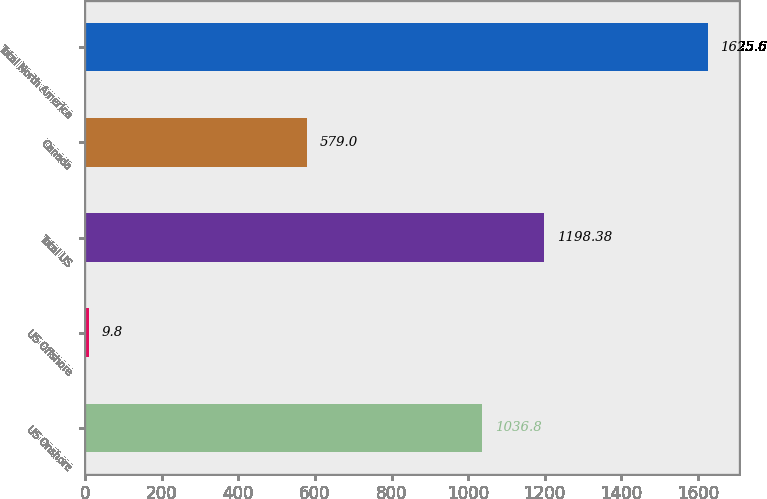Convert chart. <chart><loc_0><loc_0><loc_500><loc_500><bar_chart><fcel>US Onshore<fcel>US Offshore<fcel>Total US<fcel>Canada<fcel>Total North America<nl><fcel>1036.8<fcel>9.8<fcel>1198.38<fcel>579<fcel>1625.6<nl></chart> 